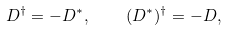<formula> <loc_0><loc_0><loc_500><loc_500>D ^ { \dag } = - D ^ { * } , \quad ( D ^ { * } ) ^ { \dag } = - D ,</formula> 